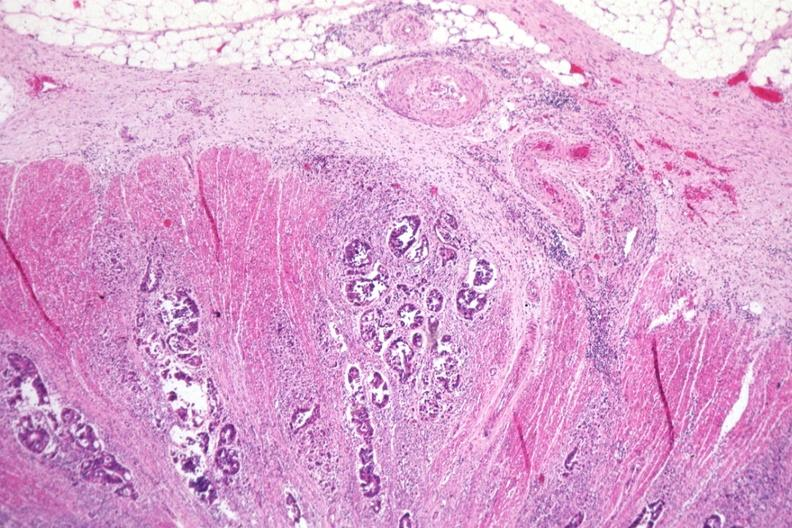s mucoepidermoid carcinoma present?
Answer the question using a single word or phrase. No 